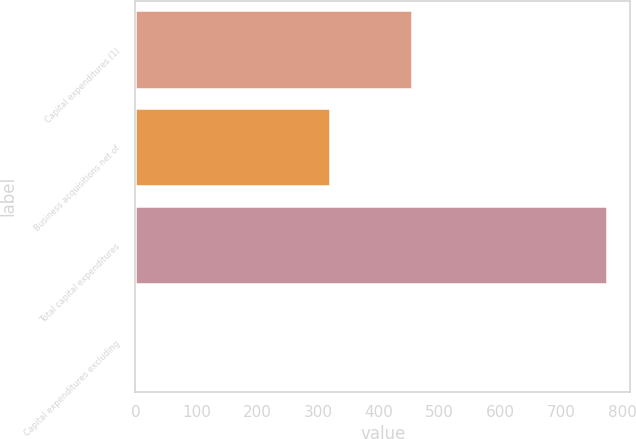<chart> <loc_0><loc_0><loc_500><loc_500><bar_chart><fcel>Capital expenditures (1)<fcel>Business acquisitions net of<fcel>Total capital expenditures<fcel>Capital expenditures excluding<nl><fcel>454<fcel>320<fcel>774<fcel>3.1<nl></chart> 